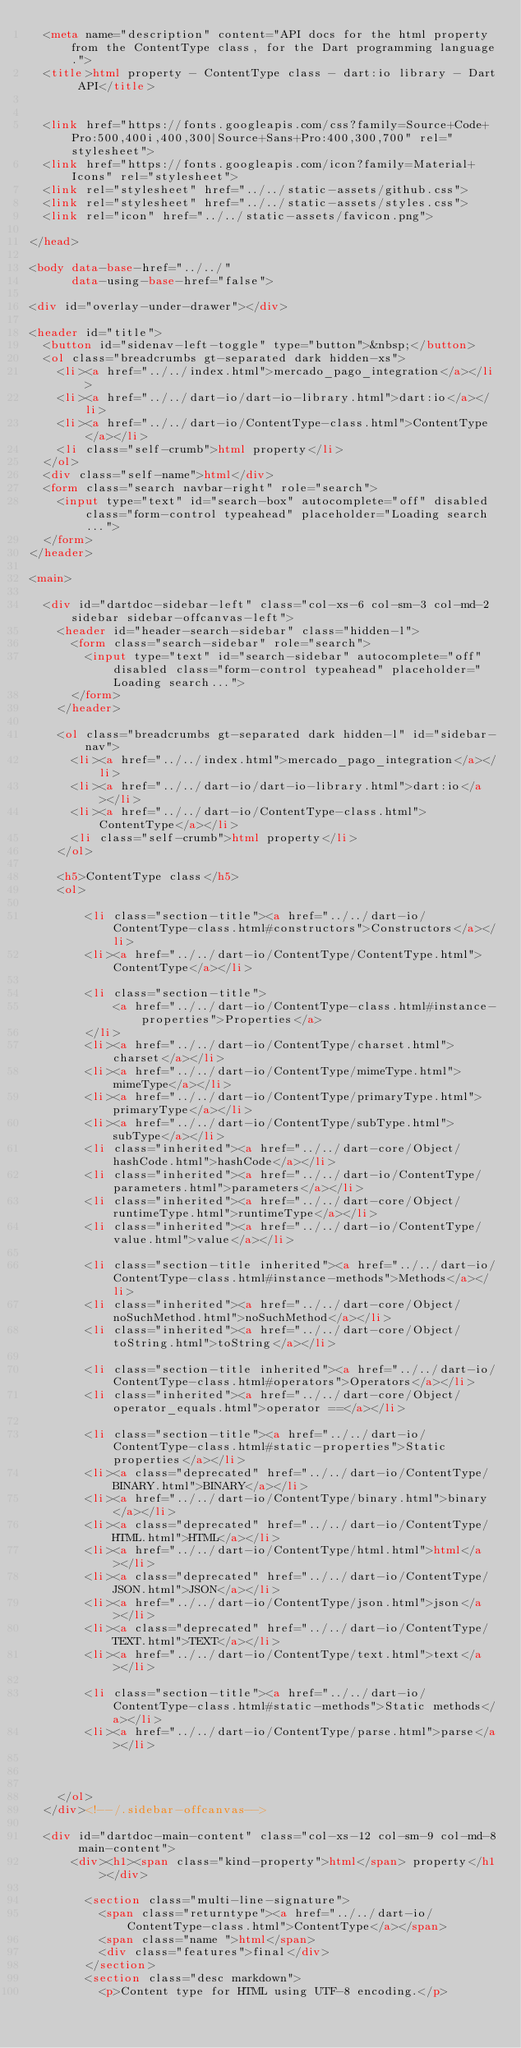Convert code to text. <code><loc_0><loc_0><loc_500><loc_500><_HTML_>  <meta name="description" content="API docs for the html property from the ContentType class, for the Dart programming language.">
  <title>html property - ContentType class - dart:io library - Dart API</title>

  
  <link href="https://fonts.googleapis.com/css?family=Source+Code+Pro:500,400i,400,300|Source+Sans+Pro:400,300,700" rel="stylesheet">
  <link href="https://fonts.googleapis.com/icon?family=Material+Icons" rel="stylesheet">
  <link rel="stylesheet" href="../../static-assets/github.css">
  <link rel="stylesheet" href="../../static-assets/styles.css">
  <link rel="icon" href="../../static-assets/favicon.png">

</head>

<body data-base-href="../../"
      data-using-base-href="false">

<div id="overlay-under-drawer"></div>

<header id="title">
  <button id="sidenav-left-toggle" type="button">&nbsp;</button>
  <ol class="breadcrumbs gt-separated dark hidden-xs">
    <li><a href="../../index.html">mercado_pago_integration</a></li>
    <li><a href="../../dart-io/dart-io-library.html">dart:io</a></li>
    <li><a href="../../dart-io/ContentType-class.html">ContentType</a></li>
    <li class="self-crumb">html property</li>
  </ol>
  <div class="self-name">html</div>
  <form class="search navbar-right" role="search">
    <input type="text" id="search-box" autocomplete="off" disabled class="form-control typeahead" placeholder="Loading search...">
  </form>
</header>

<main>

  <div id="dartdoc-sidebar-left" class="col-xs-6 col-sm-3 col-md-2 sidebar sidebar-offcanvas-left">
    <header id="header-search-sidebar" class="hidden-l">
      <form class="search-sidebar" role="search">
        <input type="text" id="search-sidebar" autocomplete="off" disabled class="form-control typeahead" placeholder="Loading search...">
      </form>
    </header>
    
    <ol class="breadcrumbs gt-separated dark hidden-l" id="sidebar-nav">
      <li><a href="../../index.html">mercado_pago_integration</a></li>
      <li><a href="../../dart-io/dart-io-library.html">dart:io</a></li>
      <li><a href="../../dart-io/ContentType-class.html">ContentType</a></li>
      <li class="self-crumb">html property</li>
    </ol>
    
    <h5>ContentType class</h5>
    <ol>
    
        <li class="section-title"><a href="../../dart-io/ContentType-class.html#constructors">Constructors</a></li>
        <li><a href="../../dart-io/ContentType/ContentType.html">ContentType</a></li>
    
        <li class="section-title">
            <a href="../../dart-io/ContentType-class.html#instance-properties">Properties</a>
        </li>
        <li><a href="../../dart-io/ContentType/charset.html">charset</a></li>
        <li><a href="../../dart-io/ContentType/mimeType.html">mimeType</a></li>
        <li><a href="../../dart-io/ContentType/primaryType.html">primaryType</a></li>
        <li><a href="../../dart-io/ContentType/subType.html">subType</a></li>
        <li class="inherited"><a href="../../dart-core/Object/hashCode.html">hashCode</a></li>
        <li class="inherited"><a href="../../dart-io/ContentType/parameters.html">parameters</a></li>
        <li class="inherited"><a href="../../dart-core/Object/runtimeType.html">runtimeType</a></li>
        <li class="inherited"><a href="../../dart-io/ContentType/value.html">value</a></li>
    
        <li class="section-title inherited"><a href="../../dart-io/ContentType-class.html#instance-methods">Methods</a></li>
        <li class="inherited"><a href="../../dart-core/Object/noSuchMethod.html">noSuchMethod</a></li>
        <li class="inherited"><a href="../../dart-core/Object/toString.html">toString</a></li>
    
        <li class="section-title inherited"><a href="../../dart-io/ContentType-class.html#operators">Operators</a></li>
        <li class="inherited"><a href="../../dart-core/Object/operator_equals.html">operator ==</a></li>
    
        <li class="section-title"><a href="../../dart-io/ContentType-class.html#static-properties">Static properties</a></li>
        <li><a class="deprecated" href="../../dart-io/ContentType/BINARY.html">BINARY</a></li>
        <li><a href="../../dart-io/ContentType/binary.html">binary</a></li>
        <li><a class="deprecated" href="../../dart-io/ContentType/HTML.html">HTML</a></li>
        <li><a href="../../dart-io/ContentType/html.html">html</a></li>
        <li><a class="deprecated" href="../../dart-io/ContentType/JSON.html">JSON</a></li>
        <li><a href="../../dart-io/ContentType/json.html">json</a></li>
        <li><a class="deprecated" href="../../dart-io/ContentType/TEXT.html">TEXT</a></li>
        <li><a href="../../dart-io/ContentType/text.html">text</a></li>
    
        <li class="section-title"><a href="../../dart-io/ContentType-class.html#static-methods">Static methods</a></li>
        <li><a href="../../dart-io/ContentType/parse.html">parse</a></li>
    
    
    
    </ol>
  </div><!--/.sidebar-offcanvas-->

  <div id="dartdoc-main-content" class="col-xs-12 col-sm-9 col-md-8 main-content">
      <div><h1><span class="kind-property">html</span> property</h1></div>

        <section class="multi-line-signature">
          <span class="returntype"><a href="../../dart-io/ContentType-class.html">ContentType</a></span>
          <span class="name ">html</span>
          <div class="features">final</div>
        </section>
        <section class="desc markdown">
          <p>Content type for HTML using UTF-8 encoding.</p></code> 